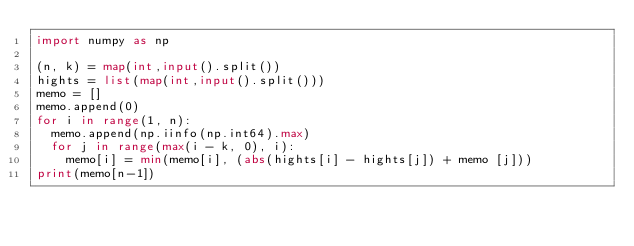<code> <loc_0><loc_0><loc_500><loc_500><_Python_>import numpy as np
 
(n, k) = map(int,input().split())
hights = list(map(int,input().split()))
memo = []
memo.append(0)
for i in range(1, n):
  memo.append(np.iinfo(np.int64).max)
  for j in range(max(i - k, 0), i):
    memo[i] = min(memo[i], (abs(hights[i] - hights[j]) + memo [j]))
print(memo[n-1])
</code> 